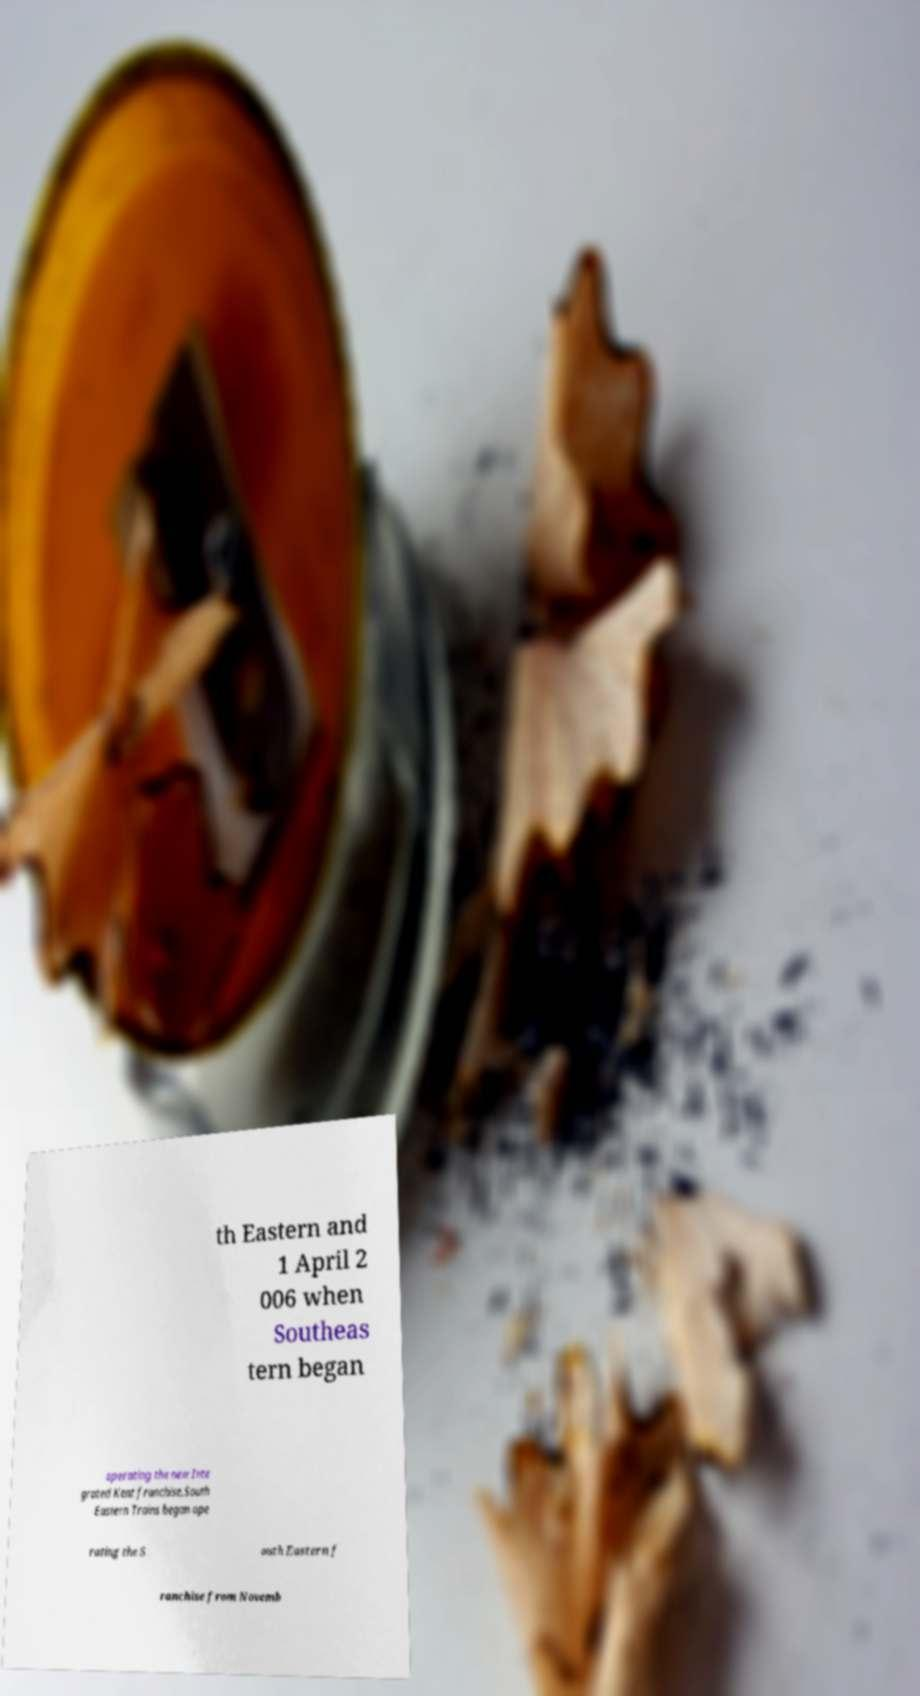Could you extract and type out the text from this image? th Eastern and 1 April 2 006 when Southeas tern began operating the new Inte grated Kent franchise.South Eastern Trains began ope rating the S outh Eastern f ranchise from Novemb 